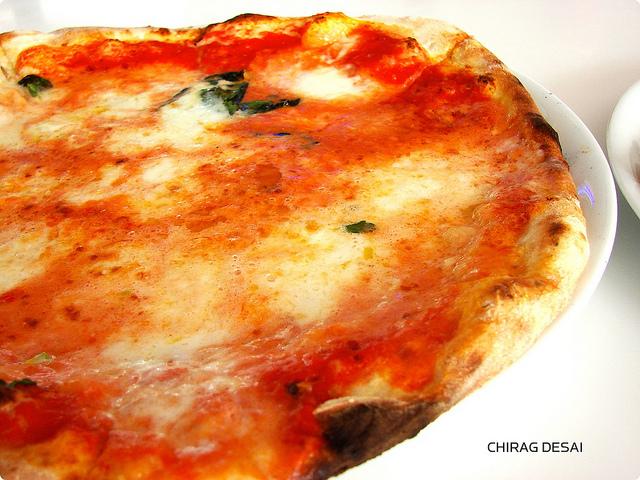What are the words printed at the bottom of the picture?
Quick response, please. Chirag desai. Is this pizza ready to eat?
Give a very brief answer. Yes. Is this pizza vegetarian?
Give a very brief answer. Yes. Is there meat on this pizza?
Concise answer only. No. Is there sausage on the pizza?
Short answer required. No. 